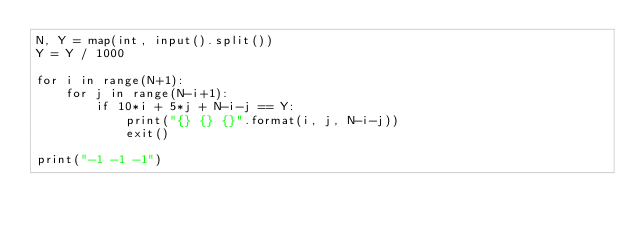Convert code to text. <code><loc_0><loc_0><loc_500><loc_500><_Python_>N, Y = map(int, input().split())
Y = Y / 1000

for i in range(N+1):
    for j in range(N-i+1):
        if 10*i + 5*j + N-i-j == Y:
            print("{} {} {}".format(i, j, N-i-j))
            exit()

print("-1 -1 -1")</code> 